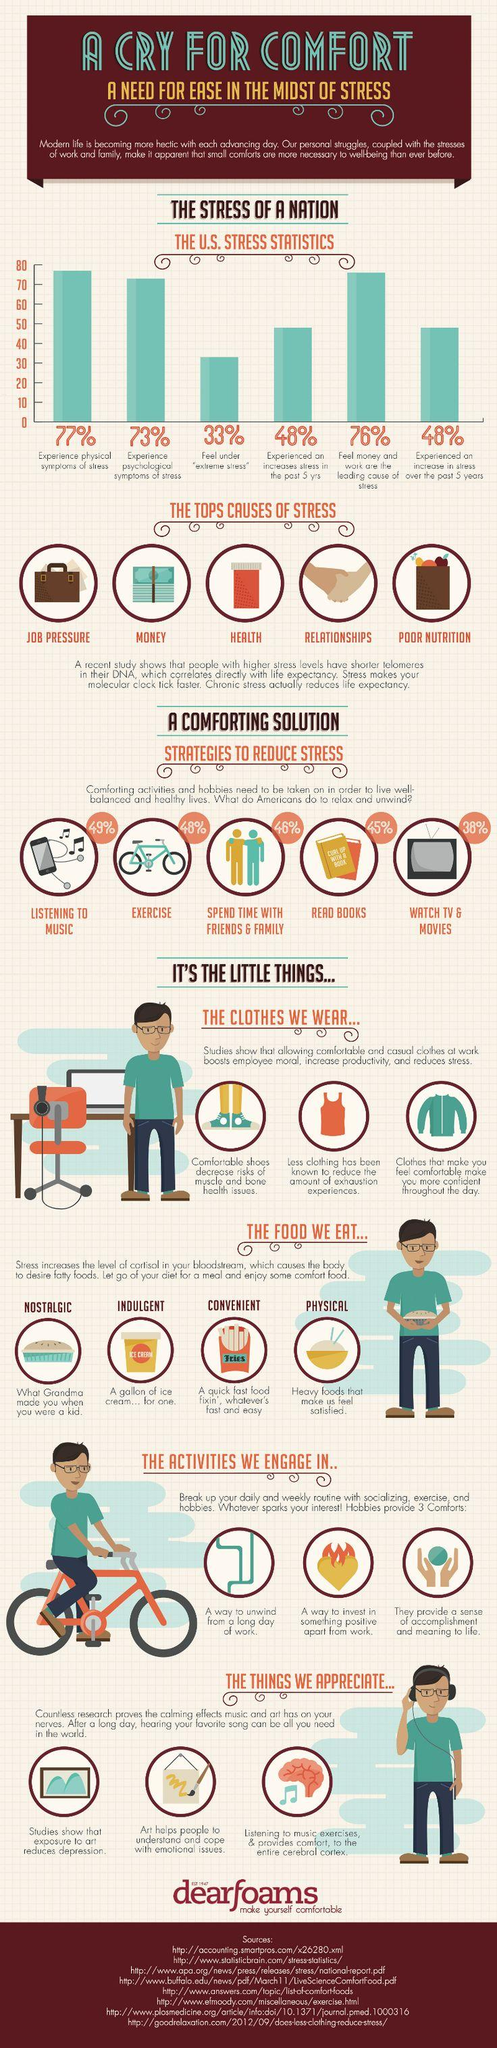Point out several critical features in this image. The reason for desiring fatty foods is linked to the level of cortisol in the body. It is estimated that there are four different types of food currently listed. Listening to music is the activity that helps me reduce stress the most. 